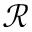<formula> <loc_0><loc_0><loc_500><loc_500>\mathcal { R }</formula> 